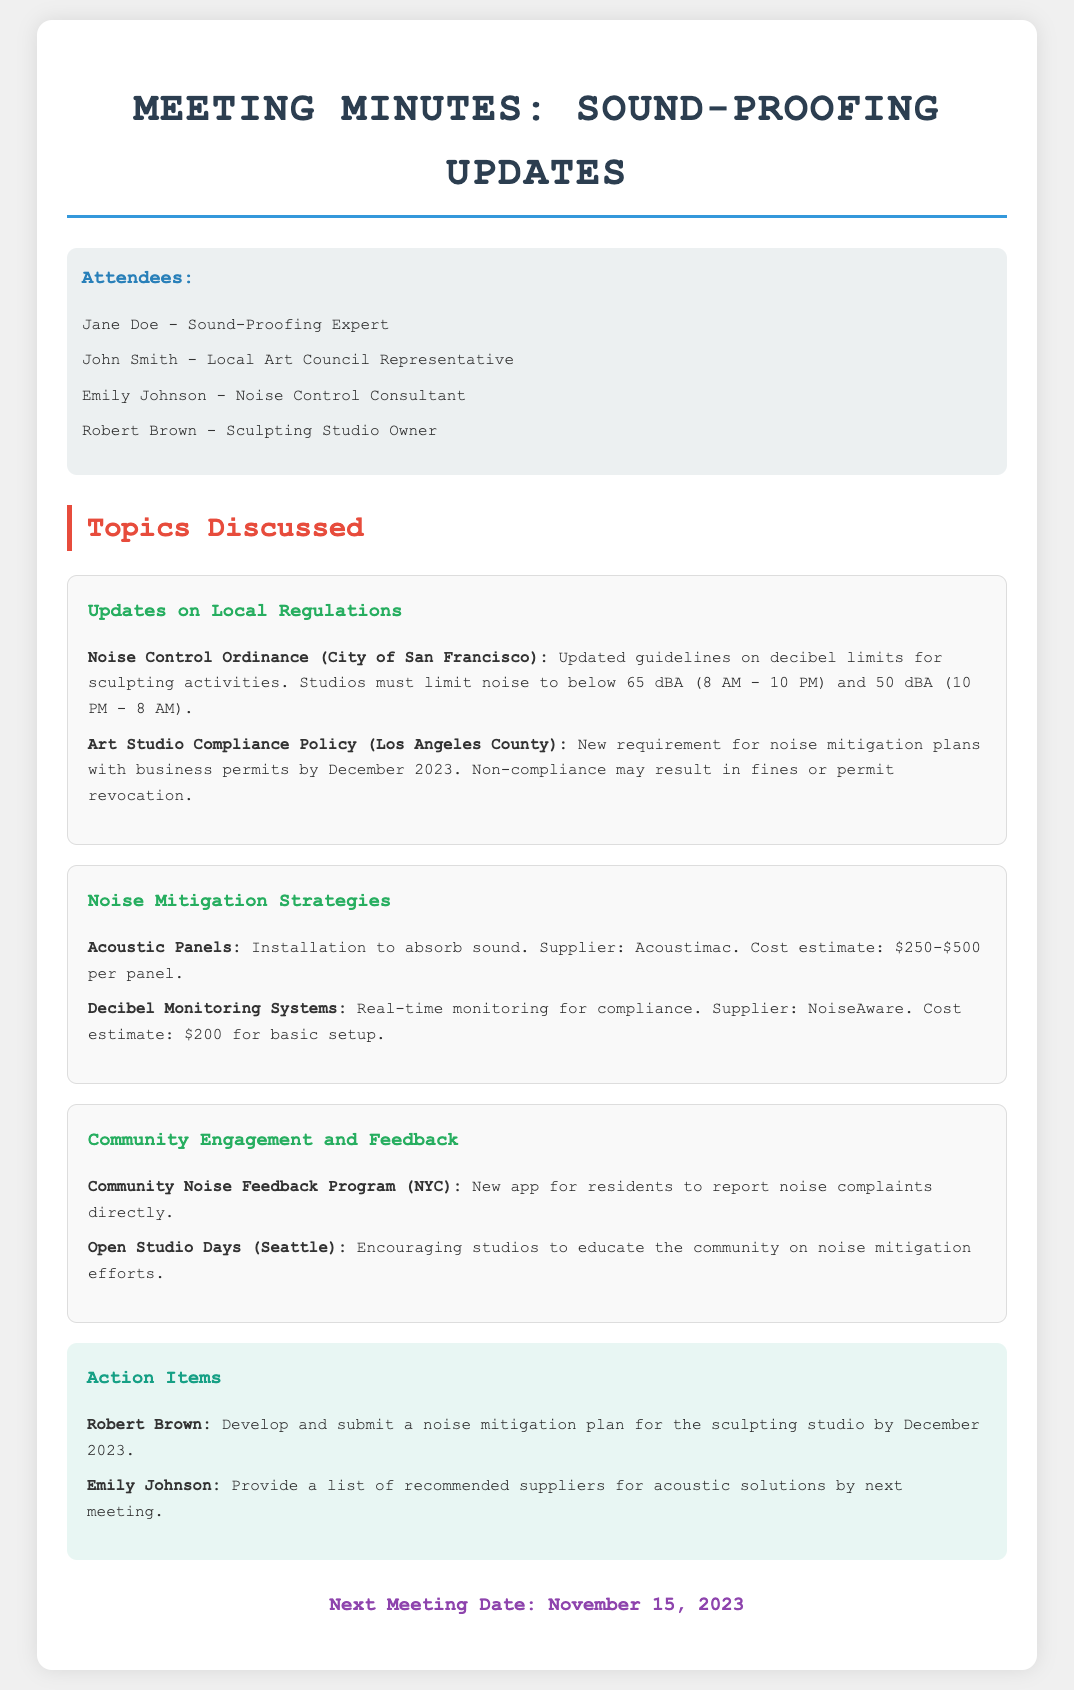What is the decibel limit for sculpting activities during the day? The document states that studios must limit noise to below 65 dBA between 8 AM and 10 PM.
Answer: 65 dBA What is the deadline for submitting noise mitigation plans in Los Angeles County? The document indicates that noise mitigation plans with business permits must be submitted by December 2023.
Answer: December 2023 Who is responsible for developing the noise mitigation plan for the sculpting studio? The action items specify that Robert Brown is tasked with developing and submitting the noise mitigation plan.
Answer: Robert Brown What is the cost estimate for installing one acoustic panel? It states in the document that the cost estimate for an acoustic panel is between $250 and $500.
Answer: $250-$500 What is the purpose of the Community Noise Feedback Program in NYC? The document describes it as a new app for residents to report noise complaints directly.
Answer: Report noise complaints What is the name of the supplier for decibel monitoring systems? According to the document, the supplier for decibel monitoring systems is NoiseAware.
Answer: NoiseAware What date is the next meeting scheduled for? The next meeting date is explicitly mentioned to be November 15, 2023.
Answer: November 15, 2023 What color is used for section headings in this document? The document uses different colors for headings, but all headings visually appear distinct and engaging.
Answer: Not applicable (multi-colored) What are the goals of Open Studio Days mentioned in Seattle? The document states that the goal is to encourage studios to educate the community on noise mitigation efforts.
Answer: Educate the community 